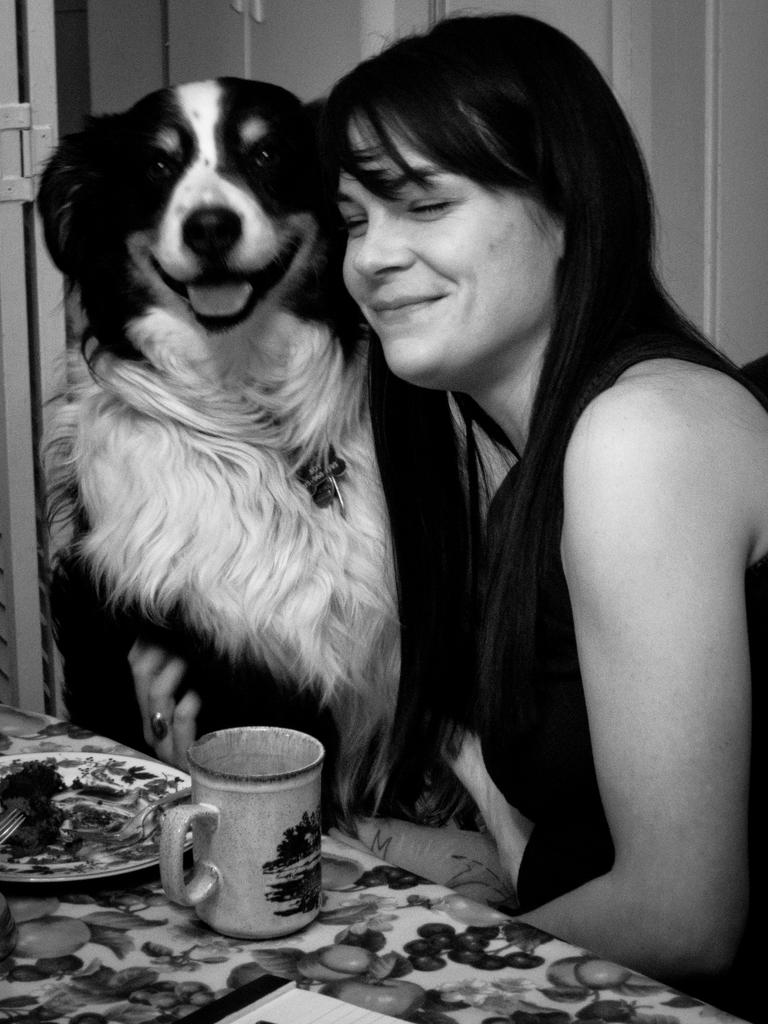Who or what is present in the image along with the person? There is a dog in the image along with the person. What is the location of the person and the dog in the image? The person and the dog are in front of a table in the image. What items can be seen on the table in the image? There is a plate and a cup on the table in the image. What type of scarecrow is standing next to the person in the image? There is no scarecrow present in the image; it features a person and a dog in front of a table. How does the dog's tail wag in the image? The image does not show the dog's tail wagging, as it only depicts the dog's body and not its movements. 